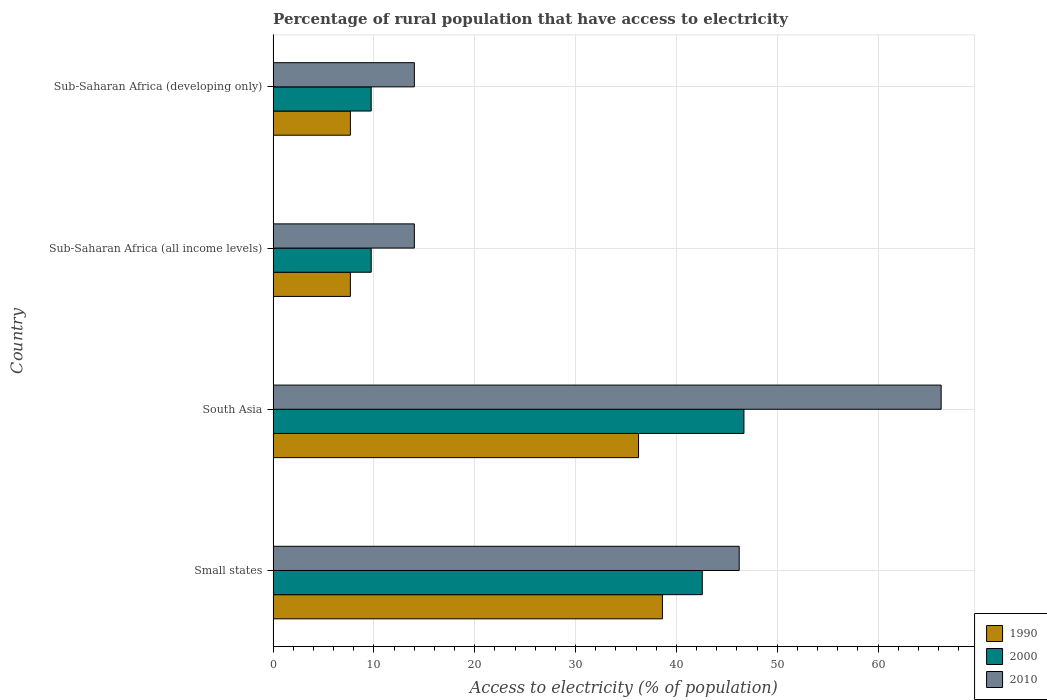Are the number of bars on each tick of the Y-axis equal?
Provide a short and direct response. Yes. How many bars are there on the 3rd tick from the top?
Keep it short and to the point. 3. What is the label of the 4th group of bars from the top?
Offer a terse response. Small states. What is the percentage of rural population that have access to electricity in 1990 in Sub-Saharan Africa (developing only)?
Provide a short and direct response. 7.66. Across all countries, what is the maximum percentage of rural population that have access to electricity in 1990?
Offer a very short reply. 38.61. Across all countries, what is the minimum percentage of rural population that have access to electricity in 1990?
Your response must be concise. 7.66. In which country was the percentage of rural population that have access to electricity in 2010 maximum?
Offer a terse response. South Asia. In which country was the percentage of rural population that have access to electricity in 2010 minimum?
Make the answer very short. Sub-Saharan Africa (developing only). What is the total percentage of rural population that have access to electricity in 2000 in the graph?
Your answer should be compact. 108.71. What is the difference between the percentage of rural population that have access to electricity in 1990 in South Asia and that in Sub-Saharan Africa (all income levels)?
Your answer should be compact. 28.58. What is the difference between the percentage of rural population that have access to electricity in 2000 in Sub-Saharan Africa (all income levels) and the percentage of rural population that have access to electricity in 2010 in South Asia?
Keep it short and to the point. -56.52. What is the average percentage of rural population that have access to electricity in 1990 per country?
Offer a very short reply. 22.54. What is the difference between the percentage of rural population that have access to electricity in 2010 and percentage of rural population that have access to electricity in 2000 in Sub-Saharan Africa (developing only)?
Your response must be concise. 4.28. What is the ratio of the percentage of rural population that have access to electricity in 1990 in South Asia to that in Sub-Saharan Africa (all income levels)?
Give a very brief answer. 4.73. Is the percentage of rural population that have access to electricity in 1990 in South Asia less than that in Sub-Saharan Africa (developing only)?
Provide a short and direct response. No. Is the difference between the percentage of rural population that have access to electricity in 2010 in Small states and Sub-Saharan Africa (developing only) greater than the difference between the percentage of rural population that have access to electricity in 2000 in Small states and Sub-Saharan Africa (developing only)?
Offer a terse response. No. What is the difference between the highest and the second highest percentage of rural population that have access to electricity in 2000?
Offer a very short reply. 4.13. What is the difference between the highest and the lowest percentage of rural population that have access to electricity in 1990?
Provide a short and direct response. 30.95. Is the sum of the percentage of rural population that have access to electricity in 2000 in South Asia and Sub-Saharan Africa (all income levels) greater than the maximum percentage of rural population that have access to electricity in 1990 across all countries?
Give a very brief answer. Yes. What does the 2nd bar from the top in Sub-Saharan Africa (all income levels) represents?
Your answer should be compact. 2000. What does the 2nd bar from the bottom in Small states represents?
Provide a succinct answer. 2000. Is it the case that in every country, the sum of the percentage of rural population that have access to electricity in 2000 and percentage of rural population that have access to electricity in 2010 is greater than the percentage of rural population that have access to electricity in 1990?
Make the answer very short. Yes. Are the values on the major ticks of X-axis written in scientific E-notation?
Offer a terse response. No. Does the graph contain any zero values?
Ensure brevity in your answer.  No. Where does the legend appear in the graph?
Give a very brief answer. Bottom right. How many legend labels are there?
Provide a short and direct response. 3. What is the title of the graph?
Ensure brevity in your answer.  Percentage of rural population that have access to electricity. Does "2014" appear as one of the legend labels in the graph?
Provide a short and direct response. No. What is the label or title of the X-axis?
Ensure brevity in your answer.  Access to electricity (% of population). What is the label or title of the Y-axis?
Your answer should be compact. Country. What is the Access to electricity (% of population) of 1990 in Small states?
Make the answer very short. 38.61. What is the Access to electricity (% of population) in 2000 in Small states?
Keep it short and to the point. 42.56. What is the Access to electricity (% of population) of 2010 in Small states?
Your answer should be very brief. 46.22. What is the Access to electricity (% of population) of 1990 in South Asia?
Provide a succinct answer. 36.24. What is the Access to electricity (% of population) in 2000 in South Asia?
Offer a terse response. 46.69. What is the Access to electricity (% of population) of 2010 in South Asia?
Your response must be concise. 66.25. What is the Access to electricity (% of population) of 1990 in Sub-Saharan Africa (all income levels)?
Your answer should be compact. 7.66. What is the Access to electricity (% of population) of 2000 in Sub-Saharan Africa (all income levels)?
Offer a terse response. 9.73. What is the Access to electricity (% of population) of 2010 in Sub-Saharan Africa (all income levels)?
Provide a short and direct response. 14.01. What is the Access to electricity (% of population) in 1990 in Sub-Saharan Africa (developing only)?
Offer a very short reply. 7.66. What is the Access to electricity (% of population) of 2000 in Sub-Saharan Africa (developing only)?
Provide a succinct answer. 9.73. What is the Access to electricity (% of population) of 2010 in Sub-Saharan Africa (developing only)?
Make the answer very short. 14.01. Across all countries, what is the maximum Access to electricity (% of population) in 1990?
Provide a succinct answer. 38.61. Across all countries, what is the maximum Access to electricity (% of population) of 2000?
Provide a short and direct response. 46.69. Across all countries, what is the maximum Access to electricity (% of population) in 2010?
Make the answer very short. 66.25. Across all countries, what is the minimum Access to electricity (% of population) in 1990?
Your response must be concise. 7.66. Across all countries, what is the minimum Access to electricity (% of population) in 2000?
Give a very brief answer. 9.73. Across all countries, what is the minimum Access to electricity (% of population) in 2010?
Offer a terse response. 14.01. What is the total Access to electricity (% of population) in 1990 in the graph?
Offer a very short reply. 90.17. What is the total Access to electricity (% of population) in 2000 in the graph?
Your response must be concise. 108.71. What is the total Access to electricity (% of population) in 2010 in the graph?
Keep it short and to the point. 140.49. What is the difference between the Access to electricity (% of population) in 1990 in Small states and that in South Asia?
Keep it short and to the point. 2.37. What is the difference between the Access to electricity (% of population) in 2000 in Small states and that in South Asia?
Provide a short and direct response. -4.13. What is the difference between the Access to electricity (% of population) of 2010 in Small states and that in South Asia?
Your answer should be compact. -20.03. What is the difference between the Access to electricity (% of population) of 1990 in Small states and that in Sub-Saharan Africa (all income levels)?
Ensure brevity in your answer.  30.95. What is the difference between the Access to electricity (% of population) in 2000 in Small states and that in Sub-Saharan Africa (all income levels)?
Your response must be concise. 32.83. What is the difference between the Access to electricity (% of population) in 2010 in Small states and that in Sub-Saharan Africa (all income levels)?
Offer a terse response. 32.22. What is the difference between the Access to electricity (% of population) of 1990 in Small states and that in Sub-Saharan Africa (developing only)?
Offer a terse response. 30.94. What is the difference between the Access to electricity (% of population) of 2000 in Small states and that in Sub-Saharan Africa (developing only)?
Your answer should be compact. 32.83. What is the difference between the Access to electricity (% of population) in 2010 in Small states and that in Sub-Saharan Africa (developing only)?
Offer a terse response. 32.22. What is the difference between the Access to electricity (% of population) in 1990 in South Asia and that in Sub-Saharan Africa (all income levels)?
Ensure brevity in your answer.  28.58. What is the difference between the Access to electricity (% of population) in 2000 in South Asia and that in Sub-Saharan Africa (all income levels)?
Provide a short and direct response. 36.96. What is the difference between the Access to electricity (% of population) in 2010 in South Asia and that in Sub-Saharan Africa (all income levels)?
Give a very brief answer. 52.25. What is the difference between the Access to electricity (% of population) of 1990 in South Asia and that in Sub-Saharan Africa (developing only)?
Offer a very short reply. 28.58. What is the difference between the Access to electricity (% of population) of 2000 in South Asia and that in Sub-Saharan Africa (developing only)?
Your answer should be compact. 36.97. What is the difference between the Access to electricity (% of population) in 2010 in South Asia and that in Sub-Saharan Africa (developing only)?
Provide a short and direct response. 52.25. What is the difference between the Access to electricity (% of population) in 1990 in Sub-Saharan Africa (all income levels) and that in Sub-Saharan Africa (developing only)?
Offer a very short reply. -0. What is the difference between the Access to electricity (% of population) in 2000 in Sub-Saharan Africa (all income levels) and that in Sub-Saharan Africa (developing only)?
Your answer should be compact. 0. What is the difference between the Access to electricity (% of population) in 2010 in Sub-Saharan Africa (all income levels) and that in Sub-Saharan Africa (developing only)?
Offer a very short reply. 0. What is the difference between the Access to electricity (% of population) in 1990 in Small states and the Access to electricity (% of population) in 2000 in South Asia?
Keep it short and to the point. -8.09. What is the difference between the Access to electricity (% of population) in 1990 in Small states and the Access to electricity (% of population) in 2010 in South Asia?
Ensure brevity in your answer.  -27.65. What is the difference between the Access to electricity (% of population) in 2000 in Small states and the Access to electricity (% of population) in 2010 in South Asia?
Make the answer very short. -23.69. What is the difference between the Access to electricity (% of population) of 1990 in Small states and the Access to electricity (% of population) of 2000 in Sub-Saharan Africa (all income levels)?
Give a very brief answer. 28.88. What is the difference between the Access to electricity (% of population) in 1990 in Small states and the Access to electricity (% of population) in 2010 in Sub-Saharan Africa (all income levels)?
Offer a terse response. 24.6. What is the difference between the Access to electricity (% of population) of 2000 in Small states and the Access to electricity (% of population) of 2010 in Sub-Saharan Africa (all income levels)?
Your response must be concise. 28.55. What is the difference between the Access to electricity (% of population) of 1990 in Small states and the Access to electricity (% of population) of 2000 in Sub-Saharan Africa (developing only)?
Your answer should be compact. 28.88. What is the difference between the Access to electricity (% of population) of 1990 in Small states and the Access to electricity (% of population) of 2010 in Sub-Saharan Africa (developing only)?
Give a very brief answer. 24.6. What is the difference between the Access to electricity (% of population) of 2000 in Small states and the Access to electricity (% of population) of 2010 in Sub-Saharan Africa (developing only)?
Provide a succinct answer. 28.55. What is the difference between the Access to electricity (% of population) of 1990 in South Asia and the Access to electricity (% of population) of 2000 in Sub-Saharan Africa (all income levels)?
Ensure brevity in your answer.  26.51. What is the difference between the Access to electricity (% of population) in 1990 in South Asia and the Access to electricity (% of population) in 2010 in Sub-Saharan Africa (all income levels)?
Provide a succinct answer. 22.23. What is the difference between the Access to electricity (% of population) of 2000 in South Asia and the Access to electricity (% of population) of 2010 in Sub-Saharan Africa (all income levels)?
Ensure brevity in your answer.  32.69. What is the difference between the Access to electricity (% of population) of 1990 in South Asia and the Access to electricity (% of population) of 2000 in Sub-Saharan Africa (developing only)?
Provide a short and direct response. 26.51. What is the difference between the Access to electricity (% of population) of 1990 in South Asia and the Access to electricity (% of population) of 2010 in Sub-Saharan Africa (developing only)?
Ensure brevity in your answer.  22.23. What is the difference between the Access to electricity (% of population) in 2000 in South Asia and the Access to electricity (% of population) in 2010 in Sub-Saharan Africa (developing only)?
Your response must be concise. 32.69. What is the difference between the Access to electricity (% of population) in 1990 in Sub-Saharan Africa (all income levels) and the Access to electricity (% of population) in 2000 in Sub-Saharan Africa (developing only)?
Your answer should be very brief. -2.07. What is the difference between the Access to electricity (% of population) of 1990 in Sub-Saharan Africa (all income levels) and the Access to electricity (% of population) of 2010 in Sub-Saharan Africa (developing only)?
Ensure brevity in your answer.  -6.34. What is the difference between the Access to electricity (% of population) of 2000 in Sub-Saharan Africa (all income levels) and the Access to electricity (% of population) of 2010 in Sub-Saharan Africa (developing only)?
Provide a succinct answer. -4.28. What is the average Access to electricity (% of population) in 1990 per country?
Your answer should be compact. 22.54. What is the average Access to electricity (% of population) of 2000 per country?
Your answer should be compact. 27.18. What is the average Access to electricity (% of population) of 2010 per country?
Provide a short and direct response. 35.12. What is the difference between the Access to electricity (% of population) in 1990 and Access to electricity (% of population) in 2000 in Small states?
Provide a succinct answer. -3.95. What is the difference between the Access to electricity (% of population) of 1990 and Access to electricity (% of population) of 2010 in Small states?
Provide a succinct answer. -7.62. What is the difference between the Access to electricity (% of population) in 2000 and Access to electricity (% of population) in 2010 in Small states?
Provide a succinct answer. -3.66. What is the difference between the Access to electricity (% of population) in 1990 and Access to electricity (% of population) in 2000 in South Asia?
Your response must be concise. -10.45. What is the difference between the Access to electricity (% of population) of 1990 and Access to electricity (% of population) of 2010 in South Asia?
Offer a very short reply. -30.01. What is the difference between the Access to electricity (% of population) of 2000 and Access to electricity (% of population) of 2010 in South Asia?
Provide a short and direct response. -19.56. What is the difference between the Access to electricity (% of population) in 1990 and Access to electricity (% of population) in 2000 in Sub-Saharan Africa (all income levels)?
Keep it short and to the point. -2.07. What is the difference between the Access to electricity (% of population) in 1990 and Access to electricity (% of population) in 2010 in Sub-Saharan Africa (all income levels)?
Ensure brevity in your answer.  -6.35. What is the difference between the Access to electricity (% of population) in 2000 and Access to electricity (% of population) in 2010 in Sub-Saharan Africa (all income levels)?
Provide a succinct answer. -4.28. What is the difference between the Access to electricity (% of population) in 1990 and Access to electricity (% of population) in 2000 in Sub-Saharan Africa (developing only)?
Offer a terse response. -2.06. What is the difference between the Access to electricity (% of population) of 1990 and Access to electricity (% of population) of 2010 in Sub-Saharan Africa (developing only)?
Your answer should be very brief. -6.34. What is the difference between the Access to electricity (% of population) of 2000 and Access to electricity (% of population) of 2010 in Sub-Saharan Africa (developing only)?
Your answer should be compact. -4.28. What is the ratio of the Access to electricity (% of population) of 1990 in Small states to that in South Asia?
Give a very brief answer. 1.07. What is the ratio of the Access to electricity (% of population) of 2000 in Small states to that in South Asia?
Provide a succinct answer. 0.91. What is the ratio of the Access to electricity (% of population) of 2010 in Small states to that in South Asia?
Your response must be concise. 0.7. What is the ratio of the Access to electricity (% of population) of 1990 in Small states to that in Sub-Saharan Africa (all income levels)?
Keep it short and to the point. 5.04. What is the ratio of the Access to electricity (% of population) in 2000 in Small states to that in Sub-Saharan Africa (all income levels)?
Provide a succinct answer. 4.37. What is the ratio of the Access to electricity (% of population) in 2010 in Small states to that in Sub-Saharan Africa (all income levels)?
Provide a succinct answer. 3.3. What is the ratio of the Access to electricity (% of population) of 1990 in Small states to that in Sub-Saharan Africa (developing only)?
Offer a very short reply. 5.04. What is the ratio of the Access to electricity (% of population) of 2000 in Small states to that in Sub-Saharan Africa (developing only)?
Give a very brief answer. 4.38. What is the ratio of the Access to electricity (% of population) of 2010 in Small states to that in Sub-Saharan Africa (developing only)?
Provide a short and direct response. 3.3. What is the ratio of the Access to electricity (% of population) of 1990 in South Asia to that in Sub-Saharan Africa (all income levels)?
Your answer should be very brief. 4.73. What is the ratio of the Access to electricity (% of population) in 2000 in South Asia to that in Sub-Saharan Africa (all income levels)?
Make the answer very short. 4.8. What is the ratio of the Access to electricity (% of population) in 2010 in South Asia to that in Sub-Saharan Africa (all income levels)?
Offer a very short reply. 4.73. What is the ratio of the Access to electricity (% of population) in 1990 in South Asia to that in Sub-Saharan Africa (developing only)?
Give a very brief answer. 4.73. What is the ratio of the Access to electricity (% of population) of 2000 in South Asia to that in Sub-Saharan Africa (developing only)?
Make the answer very short. 4.8. What is the ratio of the Access to electricity (% of population) in 2010 in South Asia to that in Sub-Saharan Africa (developing only)?
Provide a succinct answer. 4.73. What is the ratio of the Access to electricity (% of population) in 2000 in Sub-Saharan Africa (all income levels) to that in Sub-Saharan Africa (developing only)?
Give a very brief answer. 1. What is the ratio of the Access to electricity (% of population) of 2010 in Sub-Saharan Africa (all income levels) to that in Sub-Saharan Africa (developing only)?
Your response must be concise. 1. What is the difference between the highest and the second highest Access to electricity (% of population) of 1990?
Your answer should be very brief. 2.37. What is the difference between the highest and the second highest Access to electricity (% of population) in 2000?
Offer a terse response. 4.13. What is the difference between the highest and the second highest Access to electricity (% of population) in 2010?
Provide a succinct answer. 20.03. What is the difference between the highest and the lowest Access to electricity (% of population) of 1990?
Your answer should be compact. 30.95. What is the difference between the highest and the lowest Access to electricity (% of population) of 2000?
Give a very brief answer. 36.97. What is the difference between the highest and the lowest Access to electricity (% of population) of 2010?
Your answer should be compact. 52.25. 